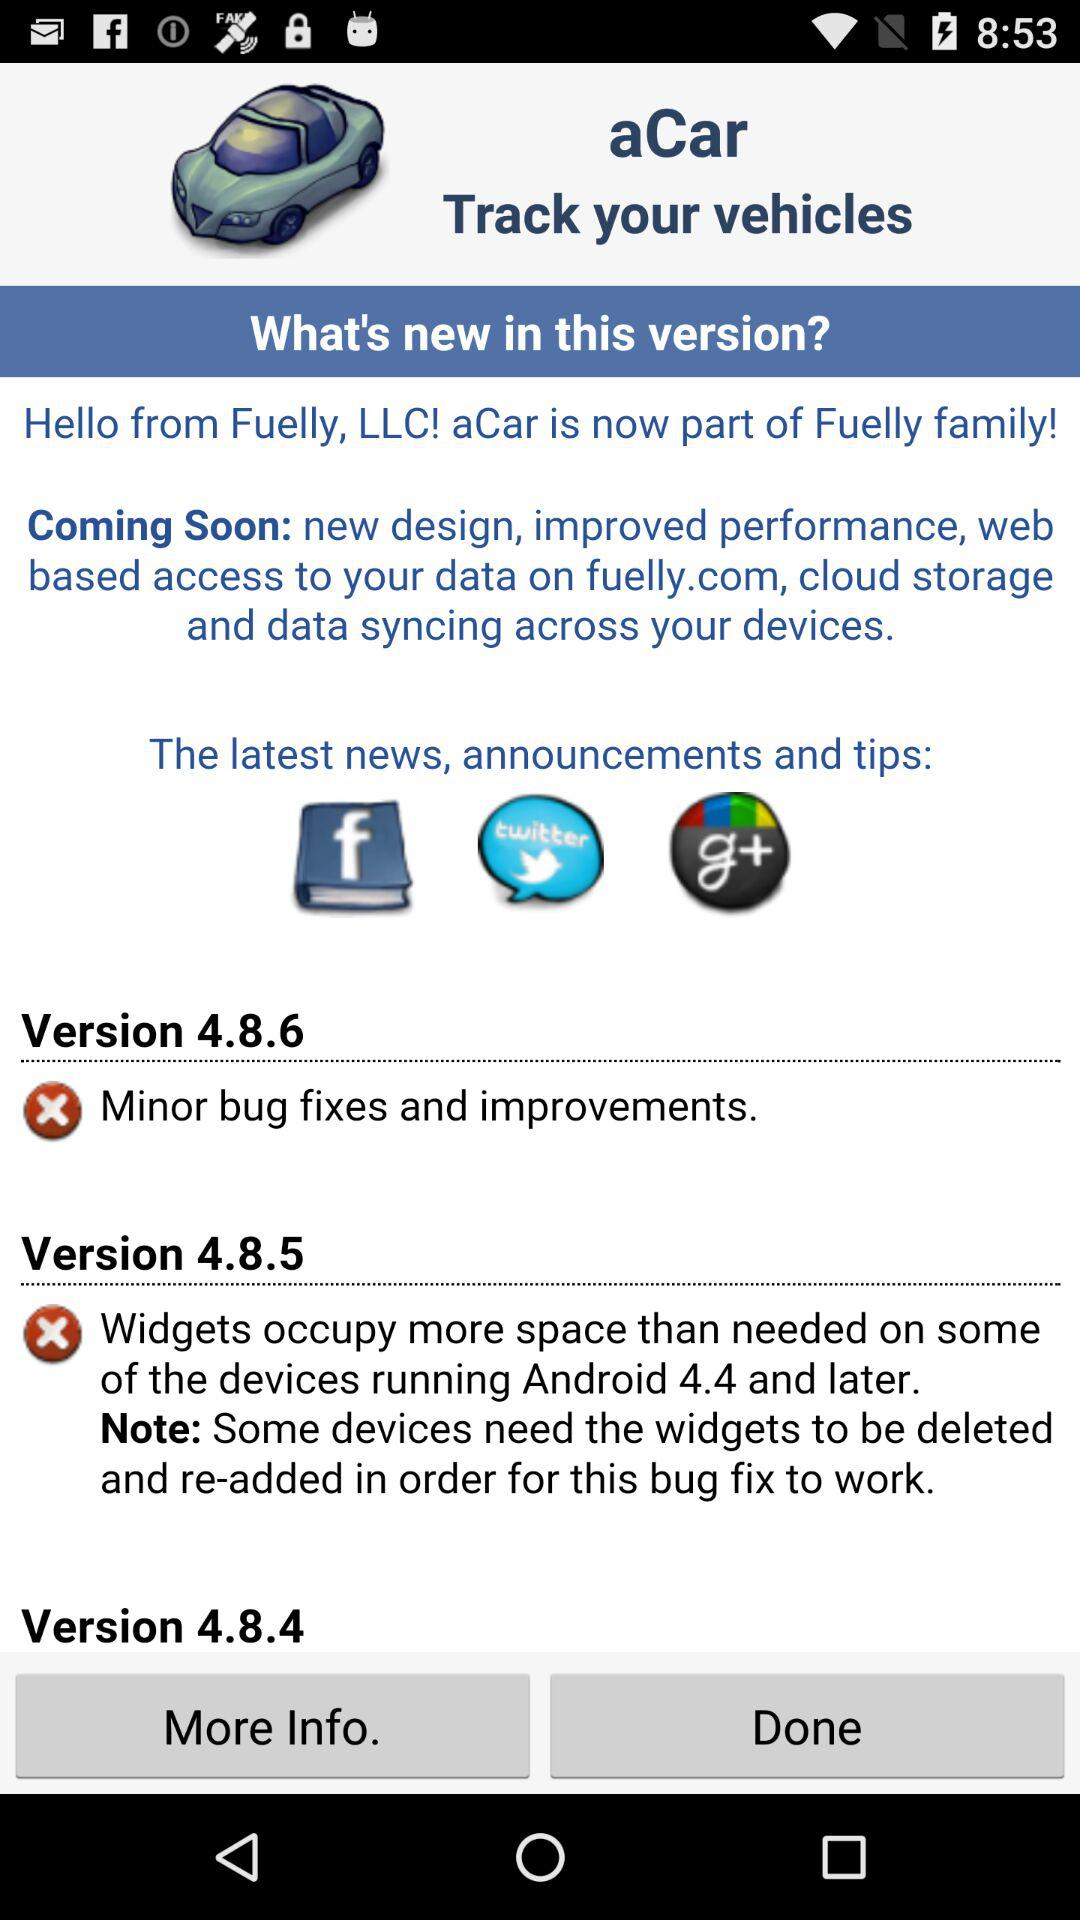What applications are shown in the latest news and announcements? The applications are "Facebook", "Twitter", and "Google ". 